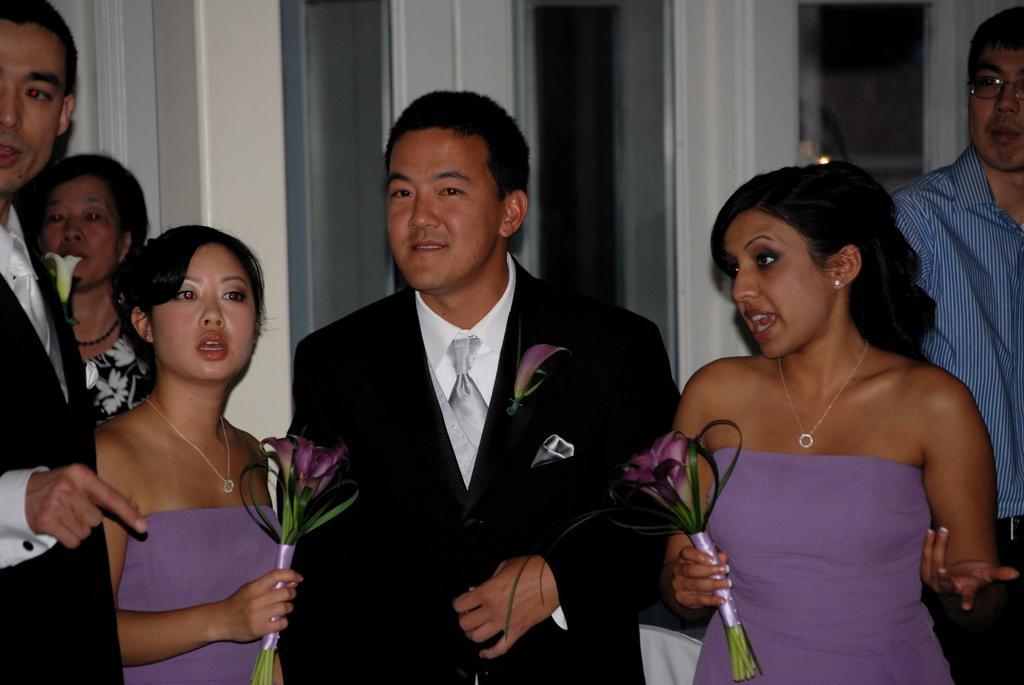How would you summarize this image in a sentence or two? In the image there are a group of people standing and some of them are talking, behind the people there is a door. 